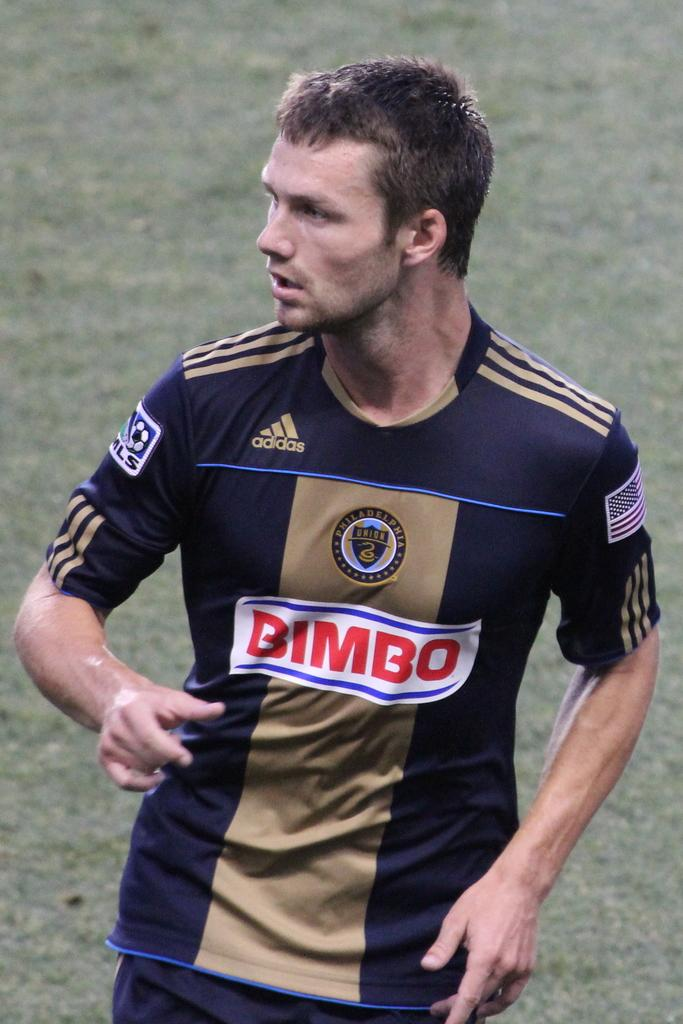<image>
Summarize the visual content of the image. A Philadelphia Union soccer player wears a black and brown adidas jersey with the word Bimbo on it. 